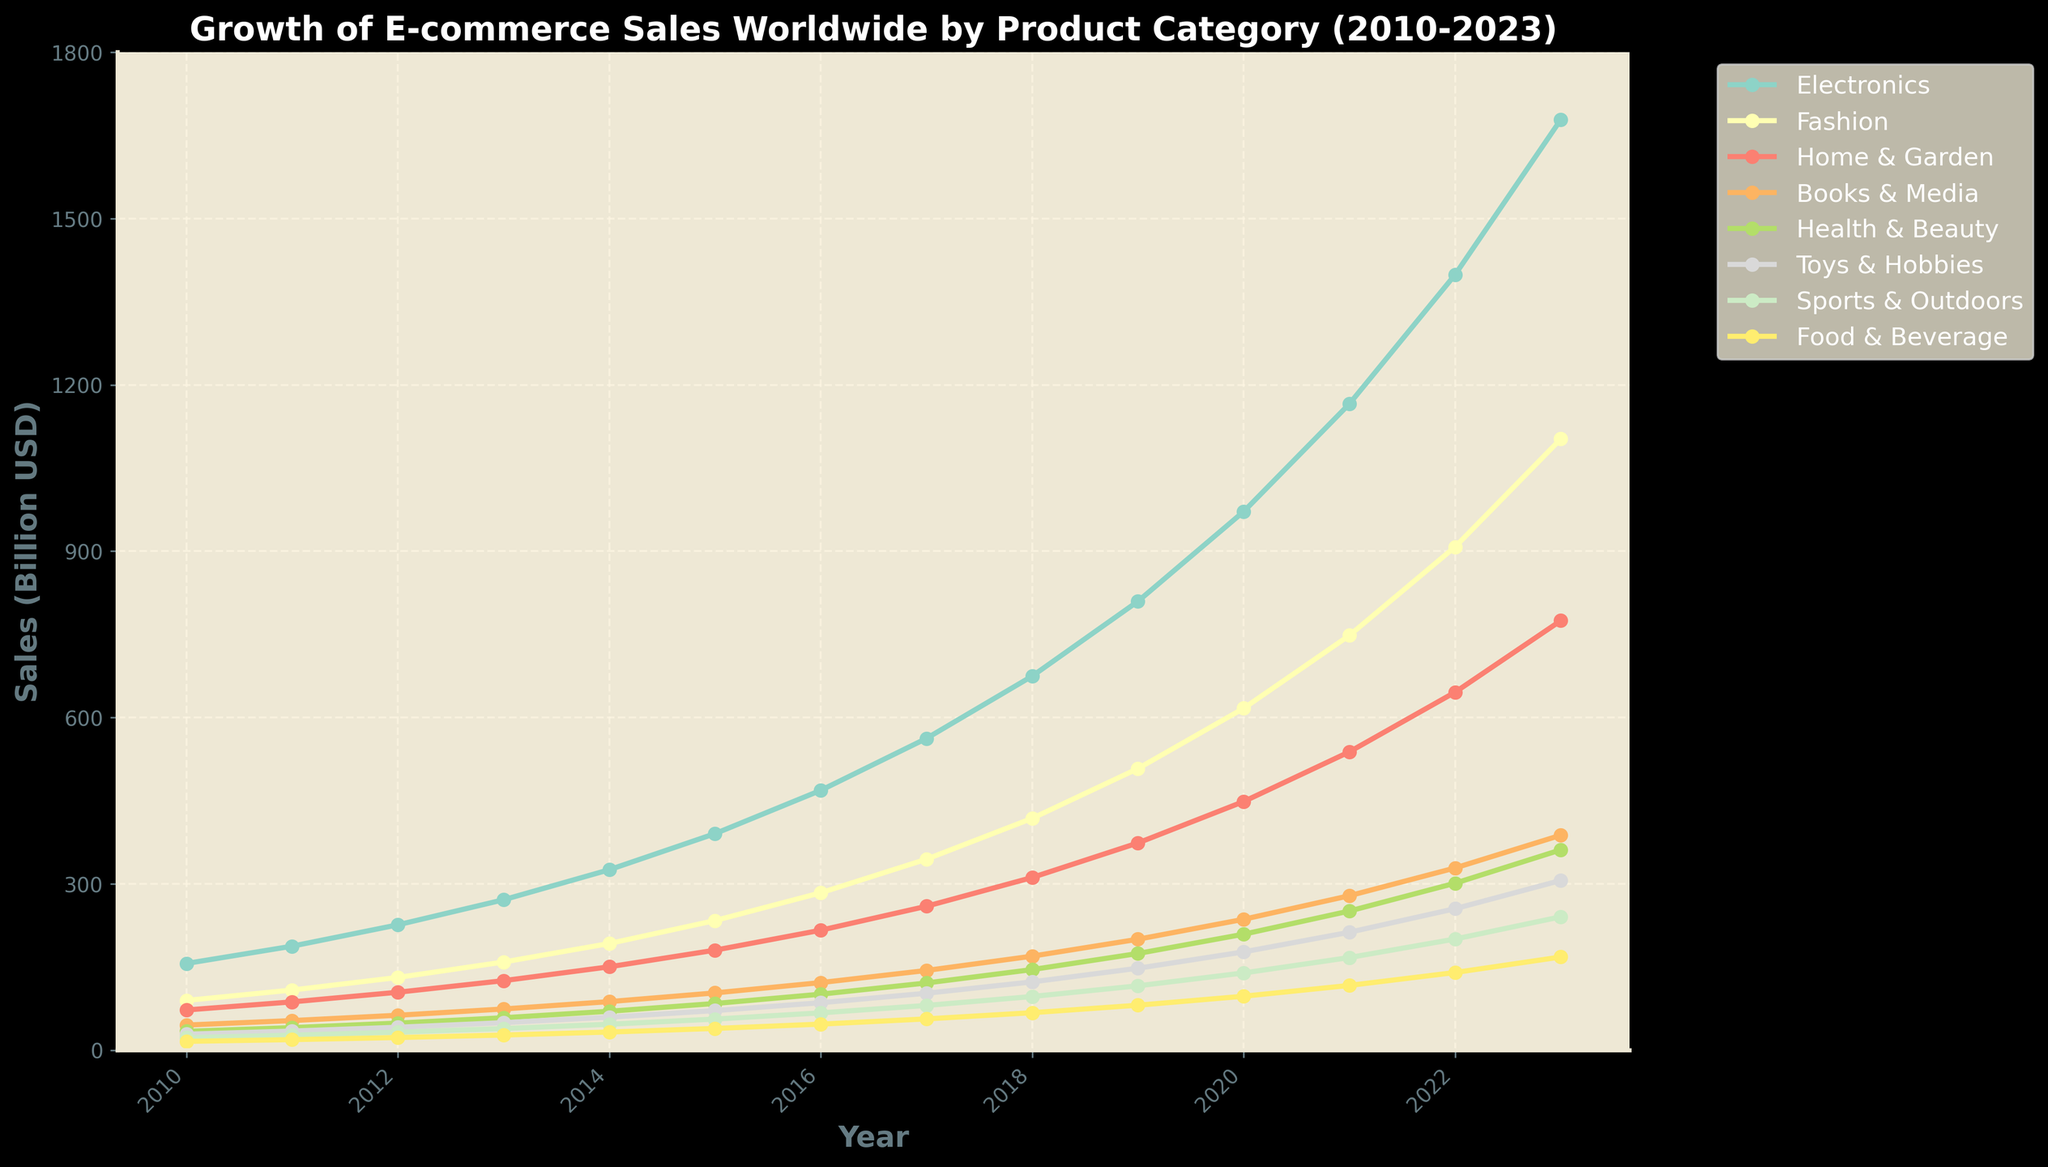What's the trend of Electronics sales from 2010 to 2023? To find the trend, we need to look at the line representing Electronics sales over the years. The line shows a steady increase from 2010 (156.2 billion USD) to 2023 (1678.6 billion USD).
Answer: Steady Increase Which product category had the highest sales in 2023? By observing the height of lines at the year 2023, the Electronics category reaches the highest point compared to other categories.
Answer: Electronics In which year did Fashion sales surpass 500 billion USD? Follow the Fashion line and see where it crosses the 500 billion USD mark. This occurs in 2019.
Answer: 2019 What is the difference in sales between Sports & Outdoors and Books & Media in 2020? Find the values of Sports & Outdoors and Books & Media for the year 2020. The values are 139.1 and 235.9 billion USD, respectively. The difference is 235.9 - 139.1 = 96.8 billion USD.
Answer: 96.8 billion USD Which category showed the most substantial increase in sales between 2015 and 2016? To find the greatest increase, calculate the difference for each category between these years. Electronics shows the highest increase: 468.5 - 390.4 = 78.1 billion USD.
Answer: Electronics How much more did Health & Beauty sales grow compared to Toys & Hobbies from 2011 to 2013? Calculate the growth for Health & Beauty and Toys & Hobbies from 2011 to 2013. For Health & Beauty: 58.3 - 40.5 = 17.8 billion USD. For Toys & Hobbies: 49.4 - 34.3 = 15.1 billion USD. The difference in growth is 17.8 - 15.1 = 2.7 billion USD.
Answer: 2.7 billion USD Which year saw the smallest growth in Home & Garden sales compared to the previous year? Calculate the year-over-year growth for Home & Garden sales, and find the smallest increment. The smallest growth is between 2012 and 2013: 125.2 - 104.3 = 20.9 billion USD.
Answer: 2013 How many product categories had sales exceeding 300 billion USD in 2022? Check the values of all categories for the year 2022. Electronics, Fashion, Home & Garden, Health & Beauty all exceed 300 billion USD, summing to 4 categories.
Answer: 4 Which product category had the least growth from 2010 to 2023? Calculate the growth for each category from 2010 to 2023. The category with the smallest increase is Food & Beverage: 167.9 - 15.7 = 152.2 billion USD.
Answer: Food & Beverage What was the average sales value for Books & Media from 2010 to 2023? Sum the Books & Media sales from each year and divide by the number of years (14). The sum is 45.1 + 53.2 + 62.8 + 74.1 + 87.4 + 103.1 + 121.7 + 143.6 + 169.4 + 199.9 + 235.9 + 278.4 + 328.5 + 387.6 = 2290.7. The average is 2290.7 / 14 ≈ 163.62.
Answer: ≈ 163.62 billion USD 